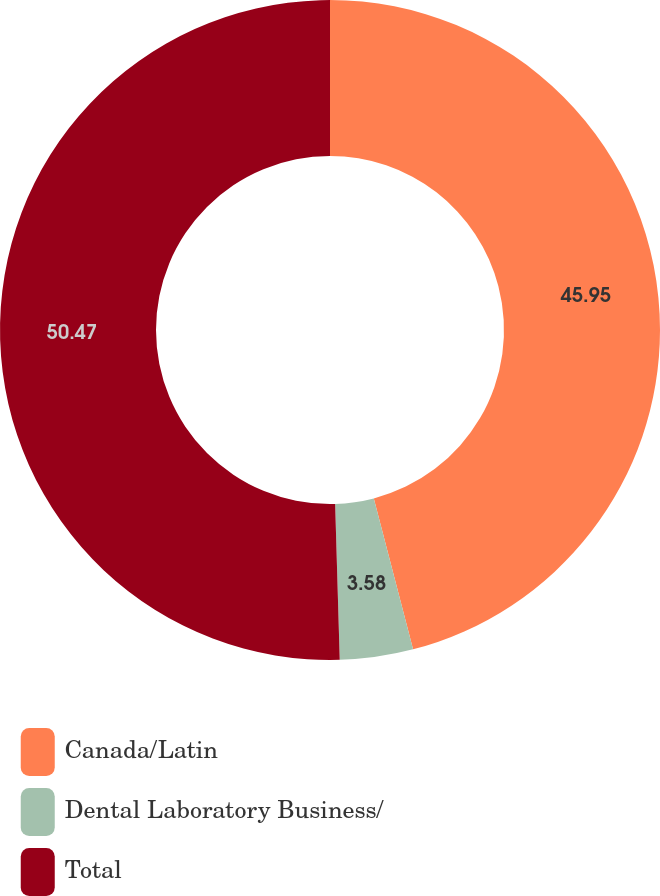Convert chart. <chart><loc_0><loc_0><loc_500><loc_500><pie_chart><fcel>Canada/Latin<fcel>Dental Laboratory Business/<fcel>Total<nl><fcel>45.95%<fcel>3.58%<fcel>50.47%<nl></chart> 